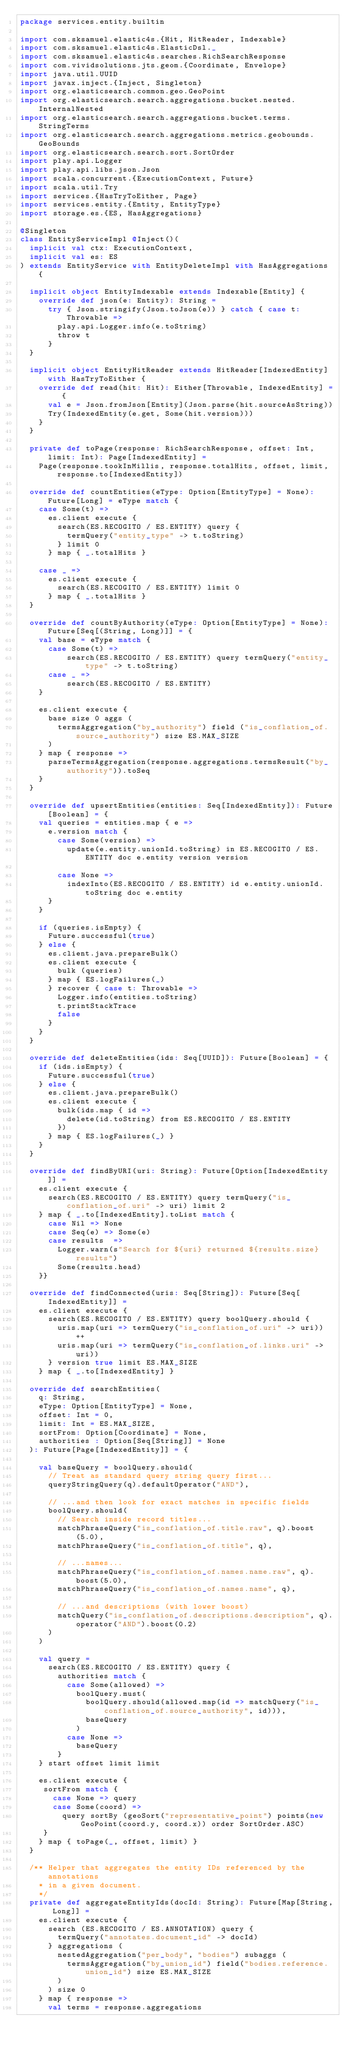<code> <loc_0><loc_0><loc_500><loc_500><_Scala_>package services.entity.builtin

import com.sksamuel.elastic4s.{Hit, HitReader, Indexable}
import com.sksamuel.elastic4s.ElasticDsl._
import com.sksamuel.elastic4s.searches.RichSearchResponse
import com.vividsolutions.jts.geom.{Coordinate, Envelope}
import java.util.UUID
import javax.inject.{Inject, Singleton}
import org.elasticsearch.common.geo.GeoPoint
import org.elasticsearch.search.aggregations.bucket.nested.InternalNested
import org.elasticsearch.search.aggregations.bucket.terms.StringTerms
import org.elasticsearch.search.aggregations.metrics.geobounds.GeoBounds
import org.elasticsearch.search.sort.SortOrder
import play.api.Logger
import play.api.libs.json.Json
import scala.concurrent.{ExecutionContext, Future}
import scala.util.Try
import services.{HasTryToEither, Page}
import services.entity.{Entity, EntityType}
import storage.es.{ES, HasAggregations}

@Singleton
class EntityServiceImpl @Inject()(
  implicit val ctx: ExecutionContext,
  implicit val es: ES
) extends EntityService with EntityDeleteImpl with HasAggregations {

  implicit object EntityIndexable extends Indexable[Entity] {
    override def json(e: Entity): String =
      try { Json.stringify(Json.toJson(e)) } catch { case t: Throwable =>
        play.api.Logger.info(e.toString)
        throw t
      }
  }

  implicit object EntityHitReader extends HitReader[IndexedEntity] with HasTryToEither {
    override def read(hit: Hit): Either[Throwable, IndexedEntity] = {
      val e = Json.fromJson[Entity](Json.parse(hit.sourceAsString))
      Try(IndexedEntity(e.get, Some(hit.version)))
    }
  }

  private def toPage(response: RichSearchResponse, offset: Int, limit: Int): Page[IndexedEntity] =
    Page(response.tookInMillis, response.totalHits, offset, limit, response.to[IndexedEntity])

  override def countEntities(eType: Option[EntityType] = None): Future[Long] = eType match {
    case Some(t) =>
      es.client execute {
        search(ES.RECOGITO / ES.ENTITY) query {
          termQuery("entity_type" -> t.toString)
        } limit 0
      } map { _.totalHits }

    case _ =>
      es.client execute {
        search(ES.RECOGITO / ES.ENTITY) limit 0
      } map { _.totalHits }
  }

  override def countByAuthority(eType: Option[EntityType] = None): Future[Seq[(String, Long)]] = {
    val base = eType match {
      case Some(t) =>
          search(ES.RECOGITO / ES.ENTITY) query termQuery("entity_type" -> t.toString)
      case _ =>
          search(ES.RECOGITO / ES.ENTITY)
    }

    es.client execute {
      base size 0 aggs (
        termsAggregation("by_authority") field ("is_conflation_of.source_authority") size ES.MAX_SIZE
      )
    } map { response =>
      parseTermsAggregation(response.aggregations.termsResult("by_authority")).toSeq
    }
  }

  override def upsertEntities(entities: Seq[IndexedEntity]): Future[Boolean] = {
    val queries = entities.map { e =>
      e.version match {
        case Some(version) =>
          update(e.entity.unionId.toString) in ES.RECOGITO / ES.ENTITY doc e.entity version version

        case None =>
          indexInto(ES.RECOGITO / ES.ENTITY) id e.entity.unionId.toString doc e.entity
      }
    }

    if (queries.isEmpty) {
      Future.successful(true)
    } else {
      es.client.java.prepareBulk()
      es.client execute {
        bulk (queries)
      } map { ES.logFailures(_)
      } recover { case t: Throwable =>
        Logger.info(entities.toString)
        t.printStackTrace
        false
      }
    }
  }

  override def deleteEntities(ids: Seq[UUID]): Future[Boolean] = {
    if (ids.isEmpty) {
      Future.successful(true)
    } else {
      es.client.java.prepareBulk()
      es.client execute {
        bulk(ids.map { id =>
          delete(id.toString) from ES.RECOGITO / ES.ENTITY
        })
      } map { ES.logFailures(_) }
    }
  }

  override def findByURI(uri: String): Future[Option[IndexedEntity]] =
    es.client execute {
      search(ES.RECOGITO / ES.ENTITY) query termQuery("is_conflation_of.uri" -> uri) limit 2
    } map { _.to[IndexedEntity].toList match {
      case Nil => None
      case Seq(e) => Some(e)
      case results  =>
        Logger.warn(s"Search for ${uri} returned ${results.size} results")
        Some(results.head)
    }}

  override def findConnected(uris: Seq[String]): Future[Seq[IndexedEntity]] =
    es.client execute {
      search(ES.RECOGITO / ES.ENTITY) query boolQuery.should {
        uris.map(uri => termQuery("is_conflation_of.uri" -> uri)) ++
        uris.map(uri => termQuery("is_conflation_of.links.uri" -> uri))
      } version true limit ES.MAX_SIZE
    } map { _.to[IndexedEntity] }

  override def searchEntities(
    q: String,
    eType: Option[EntityType] = None,
    offset: Int = 0,
    limit: Int = ES.MAX_SIZE,
    sortFrom: Option[Coordinate] = None,
    authorities : Option[Seq[String]] = None
  ): Future[Page[IndexedEntity]] = {
    
    val baseQuery = boolQuery.should(
      // Treat as standard query string query first...
      queryStringQuery(q).defaultOperator("AND"),

      // ...and then look for exact matches in specific fields
      boolQuery.should(
        // Search inside record titles...
        matchPhraseQuery("is_conflation_of.title.raw", q).boost(5.0),
        matchPhraseQuery("is_conflation_of.title", q),

        // ...names...
        matchPhraseQuery("is_conflation_of.names.name.raw", q).boost(5.0),
        matchPhraseQuery("is_conflation_of.names.name", q),

        // ...and descriptions (with lower boost)
        matchQuery("is_conflation_of.descriptions.description", q).operator("AND").boost(0.2)
      )
    )

    val query =
      search(ES.RECOGITO / ES.ENTITY) query {
        authorities match {
          case Some(allowed) =>
            boolQuery.must(
              boolQuery.should(allowed.map(id => matchQuery("is_conflation_of.source_authority", id))),
              baseQuery
            )
          case None =>
            baseQuery
        }
    } start offset limit limit

    es.client execute {
     sortFrom match {
       case None => query
       case Some(coord) =>
         query sortBy (geoSort("representative_point") points(new GeoPoint(coord.y, coord.x)) order SortOrder.ASC)
     }
    } map { toPage(_, offset, limit) }
  }
  
  /** Helper that aggregates the entity IDs referenced by the annotations
    * in a given document.
    */
  private def aggregateEntityIds(docId: String): Future[Map[String, Long]] =
    es.client execute {
      search (ES.RECOGITO / ES.ANNOTATION) query {
        termQuery("annotates.document_id" -> docId)
      } aggregations (
        nestedAggregation("per_body", "bodies") subaggs (
          termsAggregation("by_union_id") field("bodies.reference.union_id") size ES.MAX_SIZE
        )
      ) size 0
    } map { response =>
      val terms = response.aggregations</code> 